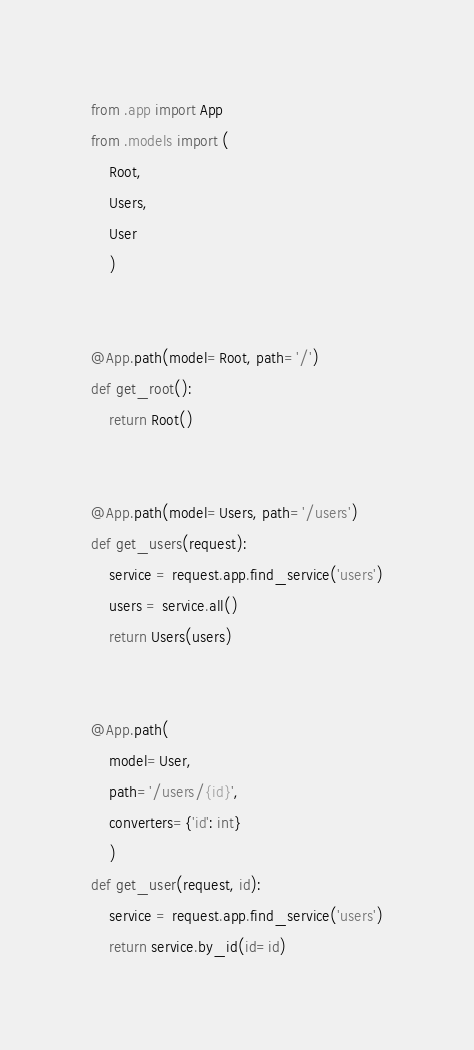Convert code to text. <code><loc_0><loc_0><loc_500><loc_500><_Python_>from .app import App
from .models import (
    Root,
    Users,
    User
    )


@App.path(model=Root, path='/')
def get_root():
    return Root()


@App.path(model=Users, path='/users')
def get_users(request):
    service = request.app.find_service('users')
    users = service.all()
    return Users(users)


@App.path(
    model=User,
    path='/users/{id}',
    converters={'id': int}
    )
def get_user(request, id):
    service = request.app.find_service('users')
    return service.by_id(id=id)
</code> 